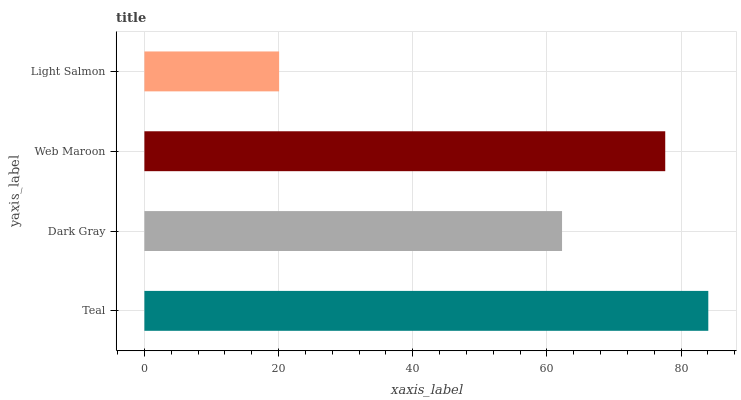Is Light Salmon the minimum?
Answer yes or no. Yes. Is Teal the maximum?
Answer yes or no. Yes. Is Dark Gray the minimum?
Answer yes or no. No. Is Dark Gray the maximum?
Answer yes or no. No. Is Teal greater than Dark Gray?
Answer yes or no. Yes. Is Dark Gray less than Teal?
Answer yes or no. Yes. Is Dark Gray greater than Teal?
Answer yes or no. No. Is Teal less than Dark Gray?
Answer yes or no. No. Is Web Maroon the high median?
Answer yes or no. Yes. Is Dark Gray the low median?
Answer yes or no. Yes. Is Dark Gray the high median?
Answer yes or no. No. Is Teal the low median?
Answer yes or no. No. 